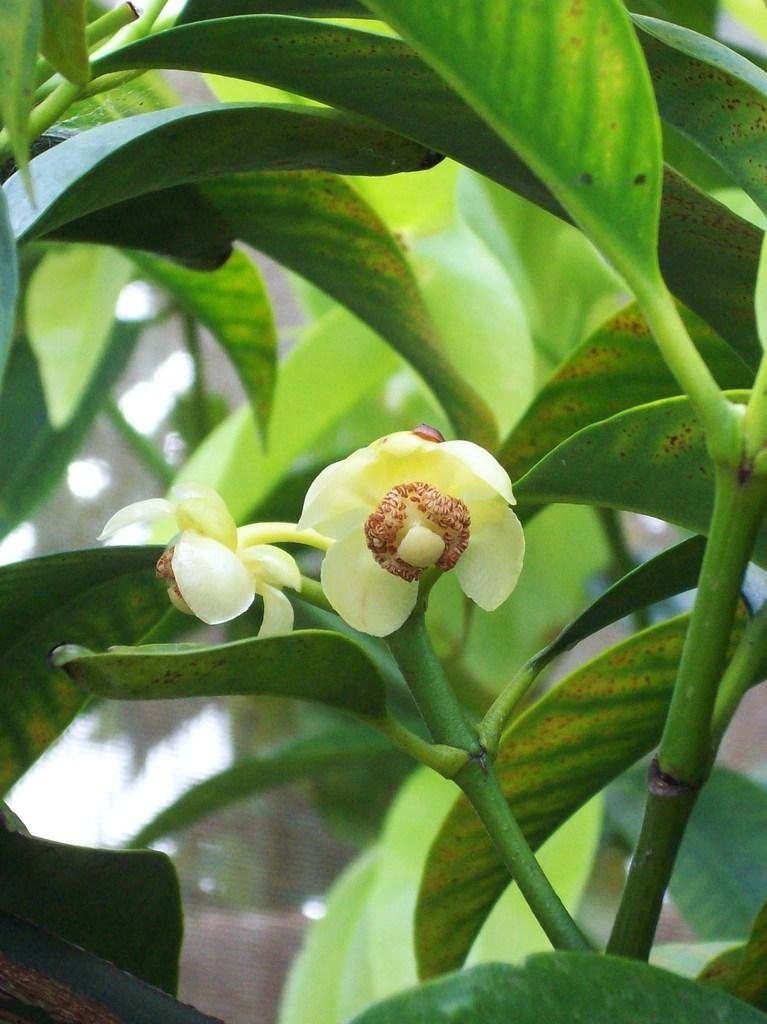What type of plant life can be seen in the image? There are flowers, leaves, and branches in the image. Can you describe the different parts of the plants in the image? Yes, the image shows flowers, leaves, and branches. What verse is being recited by the farmer in the image? There is no farmer or verse present in the image; it only features plant life. 